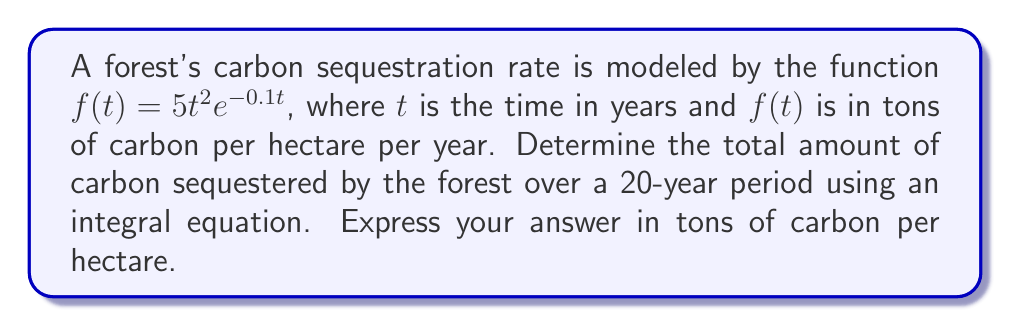Help me with this question. To solve this problem, we need to integrate the given function over the specified time period. The steps are as follows:

1) The total amount of carbon sequestered is given by the definite integral of $f(t)$ from 0 to 20:

   $$\int_0^{20} f(t) dt = \int_0^{20} 5t^2e^{-0.1t} dt$$

2) This integral doesn't have an elementary antiderivative, so we need to use integration by parts twice. Let $u = t^2$ and $dv = e^{-0.1t}dt$.

3) First integration by parts:
   $$\int t^2e^{-0.1t} dt = -10t^2e^{-0.1t} + 20\int te^{-0.1t} dt$$

4) Second integration by parts (let $u = t$ and $dv = e^{-0.1t}dt$):
   $$20\int te^{-0.1t} dt = -200te^{-0.1t} + 2000\int e^{-0.1t} dt$$

5) Combining results:
   $$\int t^2e^{-0.1t} dt = -10t^2e^{-0.1t} - 200te^{-0.1t} - 20000e^{-0.1t} + C$$

6) Now, we can evaluate the definite integral:

   $$\begin{align*}
   5\int_0^{20} t^2e^{-0.1t} dt &= 5[-10t^2e^{-0.1t} - 200te^{-0.1t} - 20000e^{-0.1t}]_0^{20} \\
   &= 5[(-10(20^2)e^{-2} - 200(20)e^{-2} - 20000e^{-2}) - (-10(0^2)e^{0} - 200(0)e^{0} - 20000e^{0})] \\
   &= 5[(-4000e^{-2} - 4000e^{-2} - 20000e^{-2}) - (-20000)] \\
   &= 5[-28000e^{-2} + 20000] \\
   &\approx 46052.5
   \end{align*}$$

Therefore, the total amount of carbon sequestered over 20 years is approximately 46052.5 tons per hectare.
Answer: 46052.5 tons/hectare 